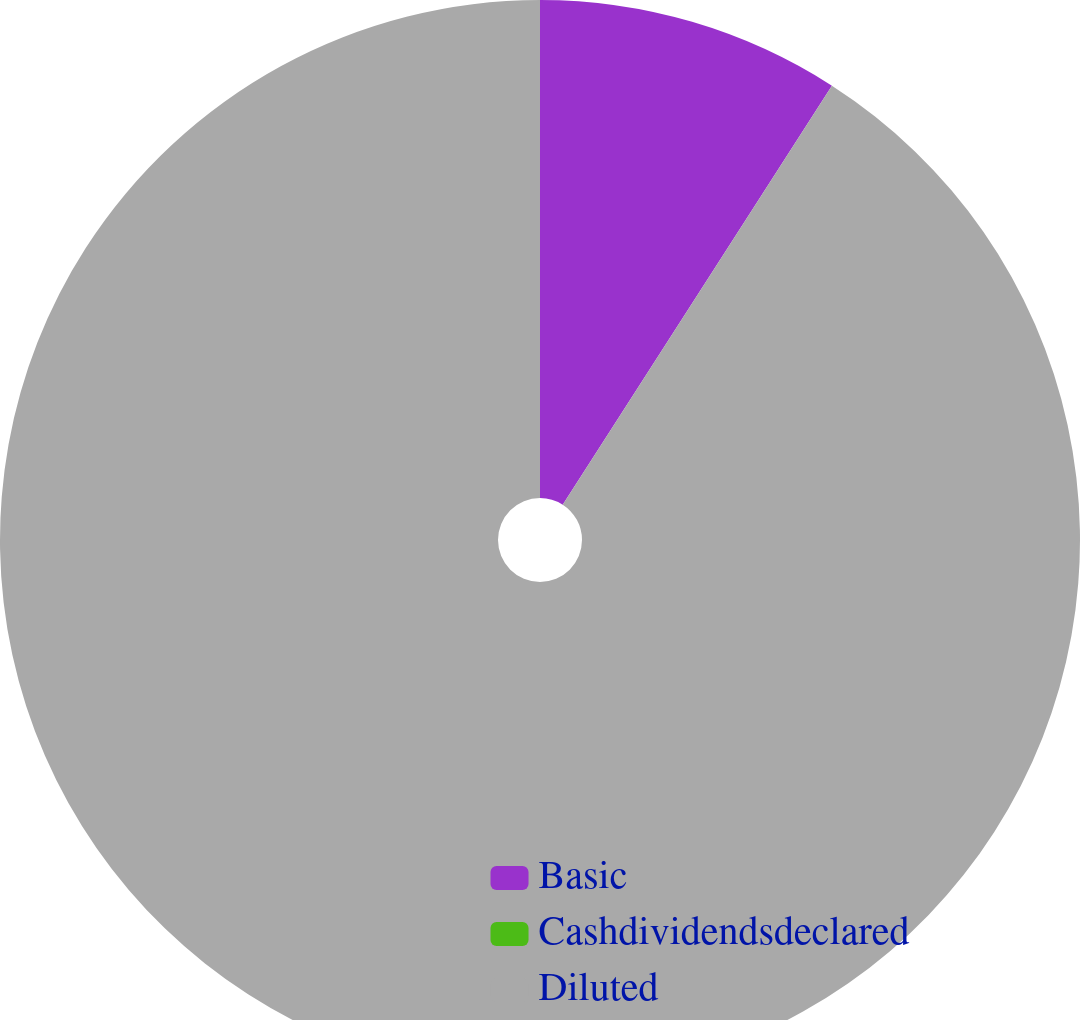<chart> <loc_0><loc_0><loc_500><loc_500><pie_chart><fcel>Basic<fcel>Cashdividendsdeclared<fcel>Diluted<nl><fcel>9.09%<fcel>0.0%<fcel>90.91%<nl></chart> 